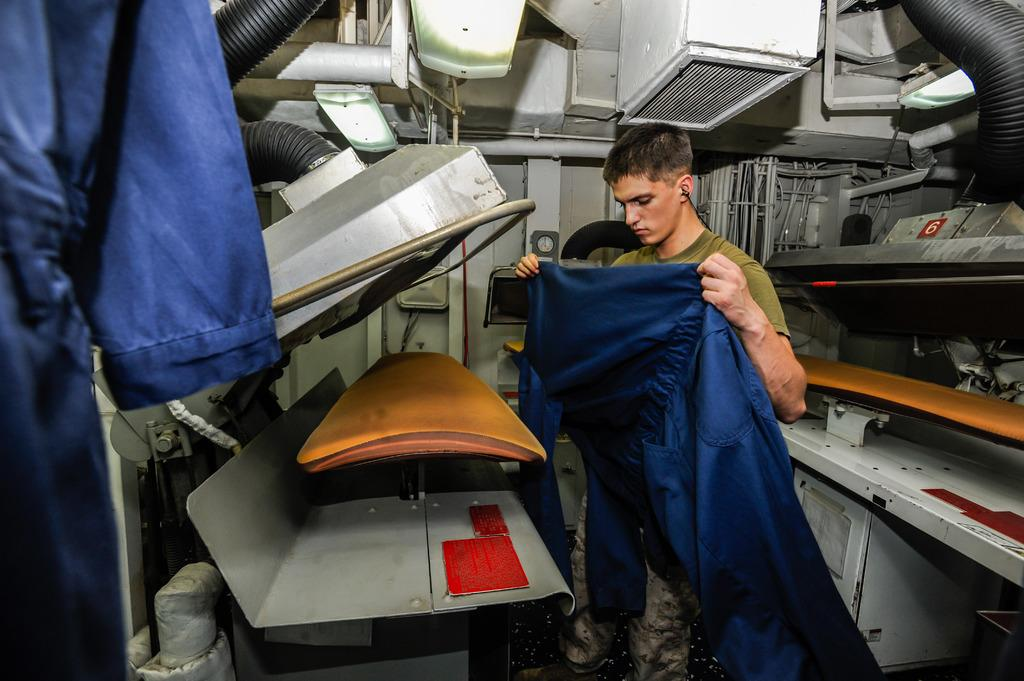Who is the person in the image? There is a man in the image. What is the man doing in the image? The man is ironing clothes. What tools or equipment is the man using to iron the clothes? There are machines involved in the ironing process. What type of gun is the man holding in the image? There is no gun present in the image; the man is ironing clothes using machines. 